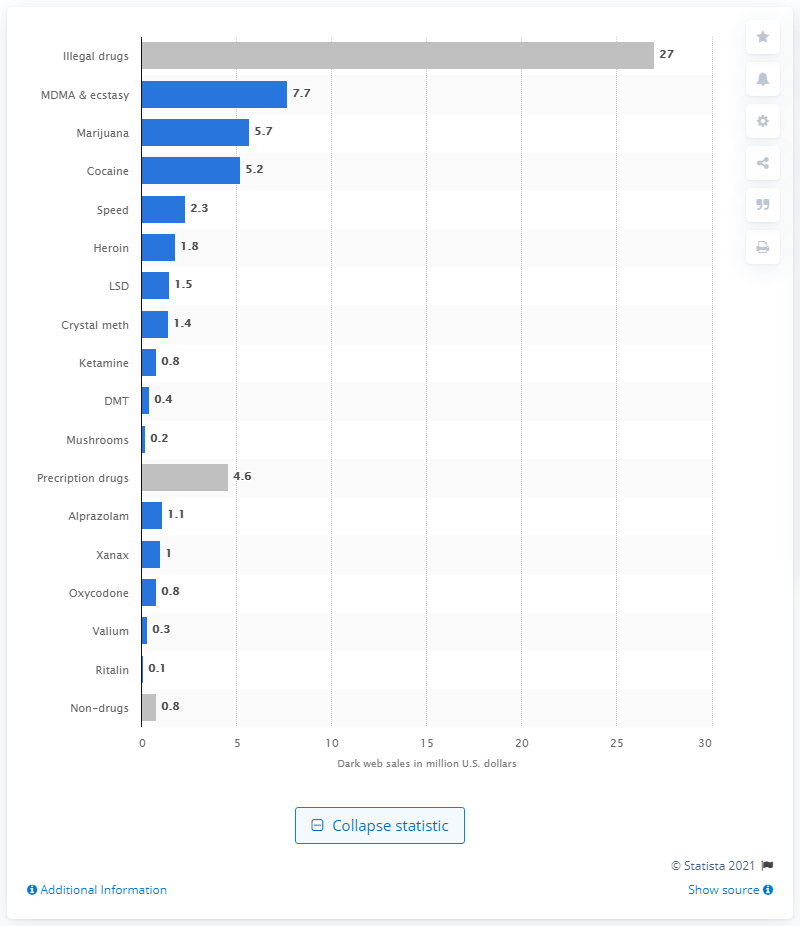Indicate a few pertinent items in this graphic. According to the information provided, cocaine accounted for approximately 5.2 billion dollars in illegal online sales. In the period from December 2013 to July 2015, the illegal drug trade on the dark web generated an estimated 27 billion U.S. dollars in revenue. 